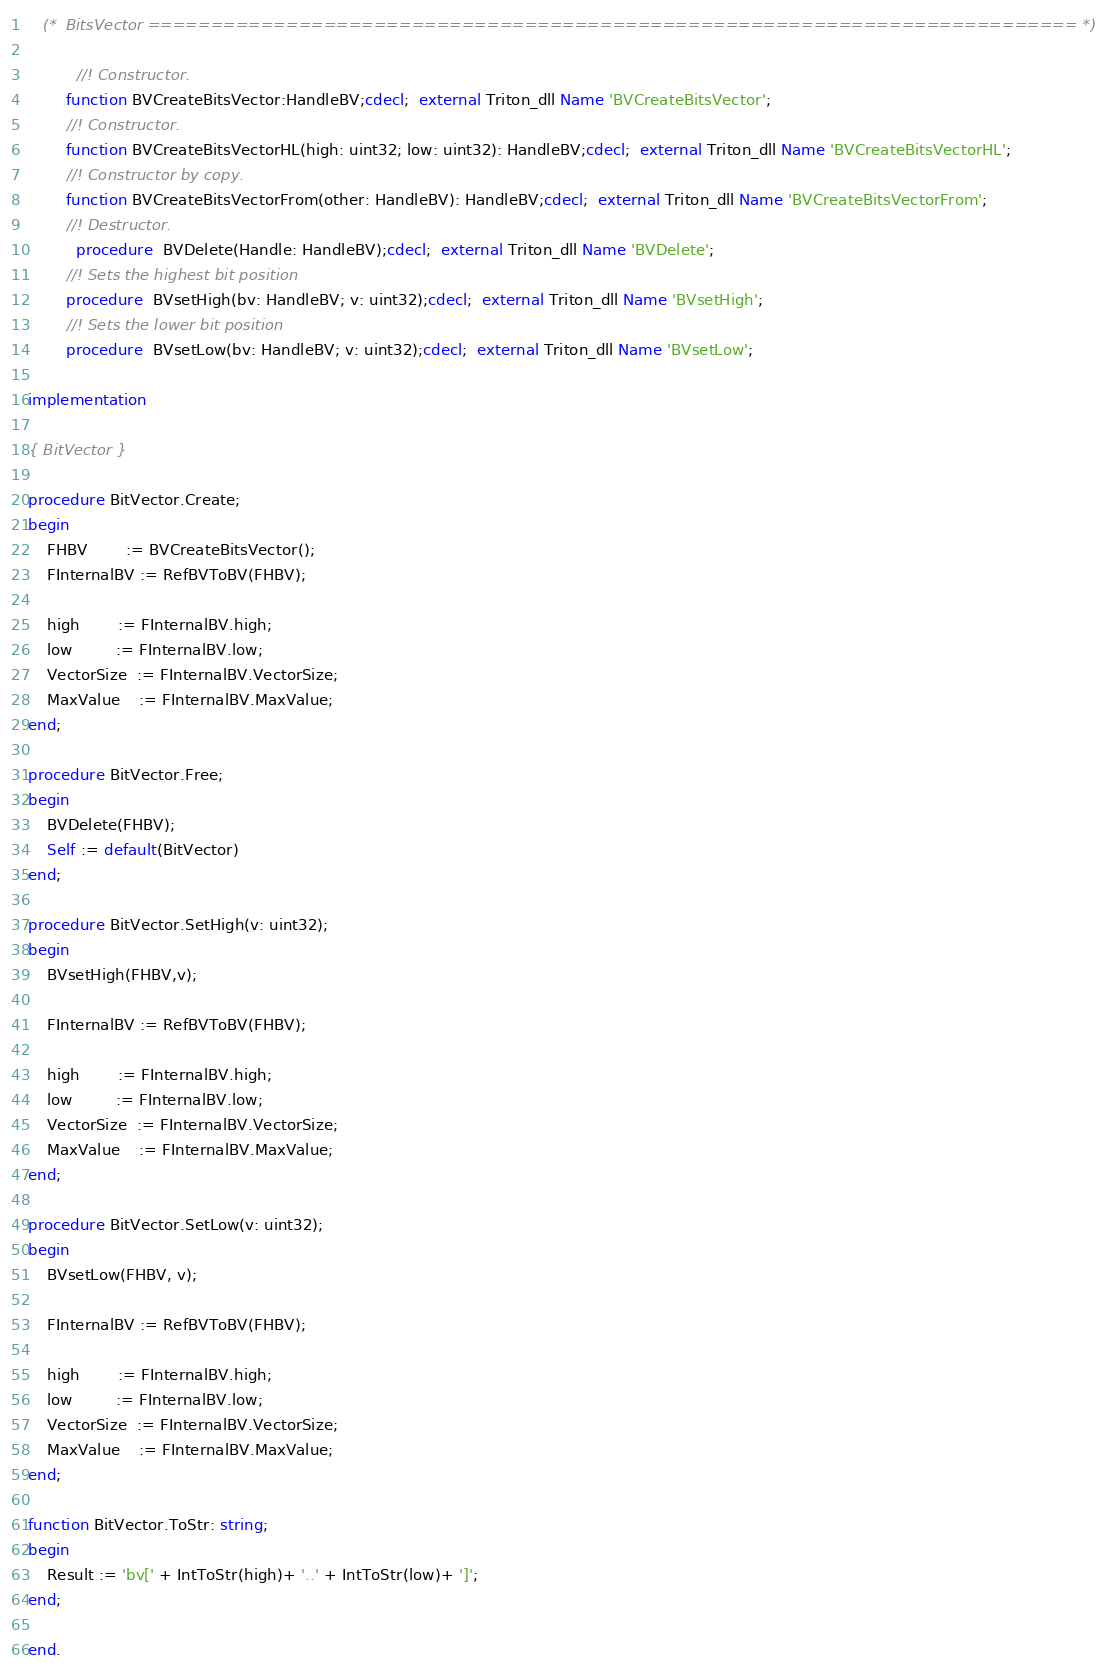Convert code to text. <code><loc_0><loc_0><loc_500><loc_500><_Pascal_>   (*  BitsVector ========================================================================== *)

	      //! Constructor.
        function BVCreateBitsVector:HandleBV;cdecl;  external Triton_dll Name 'BVCreateBitsVector';
        //! Constructor.
        function BVCreateBitsVectorHL(high: uint32; low: uint32): HandleBV;cdecl;  external Triton_dll Name 'BVCreateBitsVectorHL';
        //! Constructor by copy.
        function BVCreateBitsVectorFrom(other: HandleBV): HandleBV;cdecl;  external Triton_dll Name 'BVCreateBitsVectorFrom';
        //! Destructor.
	      procedure  BVDelete(Handle: HandleBV);cdecl;  external Triton_dll Name 'BVDelete';
        //! Sets the highest bit position
        procedure  BVsetHigh(bv: HandleBV; v: uint32);cdecl;  external Triton_dll Name 'BVsetHigh';
        //! Sets the lower bit position
        procedure  BVsetLow(bv: HandleBV; v: uint32);cdecl;  external Triton_dll Name 'BVsetLow';

implementation

{ BitVector }

procedure BitVector.Create;
begin
    FHBV        := BVCreateBitsVector();
    FInternalBV := RefBVToBV(FHBV);

    high        := FInternalBV.high;
    low         := FInternalBV.low;
    VectorSize  := FInternalBV.VectorSize;
    MaxValue    := FInternalBV.MaxValue;
end;

procedure BitVector.Free;
begin
    BVDelete(FHBV);
    Self := default(BitVector)
end;

procedure BitVector.SetHigh(v: uint32);
begin
    BVsetHigh(FHBV,v);

    FInternalBV := RefBVToBV(FHBV);

    high        := FInternalBV.high;
    low         := FInternalBV.low;
    VectorSize  := FInternalBV.VectorSize;
    MaxValue    := FInternalBV.MaxValue;
end;

procedure BitVector.SetLow(v: uint32);
begin
    BVsetLow(FHBV, v);

    FInternalBV := RefBVToBV(FHBV);

    high        := FInternalBV.high;
    low         := FInternalBV.low;
    VectorSize  := FInternalBV.VectorSize;
    MaxValue    := FInternalBV.MaxValue;
end;

function BitVector.ToStr: string;
begin
    Result := 'bv[' + IntToStr(high)+ '..' + IntToStr(low)+ ']';
end;

end.
</code> 